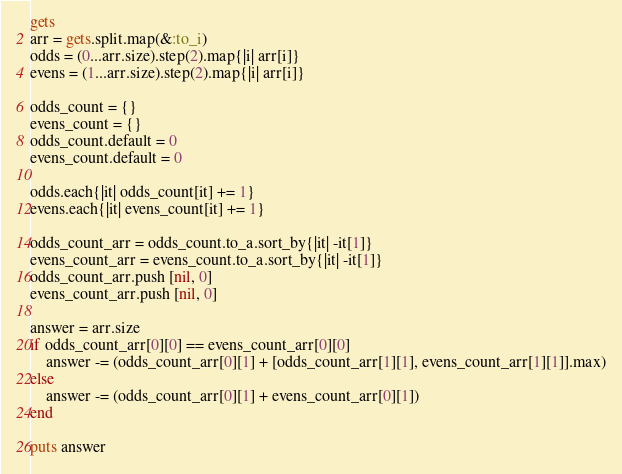Convert code to text. <code><loc_0><loc_0><loc_500><loc_500><_Ruby_>gets
arr = gets.split.map(&:to_i)
odds = (0...arr.size).step(2).map{|i| arr[i]}
evens = (1...arr.size).step(2).map{|i| arr[i]}

odds_count = {}
evens_count = {}
odds_count.default = 0
evens_count.default = 0

odds.each{|it| odds_count[it] += 1}
evens.each{|it| evens_count[it] += 1}

odds_count_arr = odds_count.to_a.sort_by{|it| -it[1]}
evens_count_arr = evens_count.to_a.sort_by{|it| -it[1]}
odds_count_arr.push [nil, 0]
evens_count_arr.push [nil, 0]

answer = arr.size
if odds_count_arr[0][0] == evens_count_arr[0][0]
    answer -= (odds_count_arr[0][1] + [odds_count_arr[1][1], evens_count_arr[1][1]].max)
else
    answer -= (odds_count_arr[0][1] + evens_count_arr[0][1])
end

puts answer
</code> 